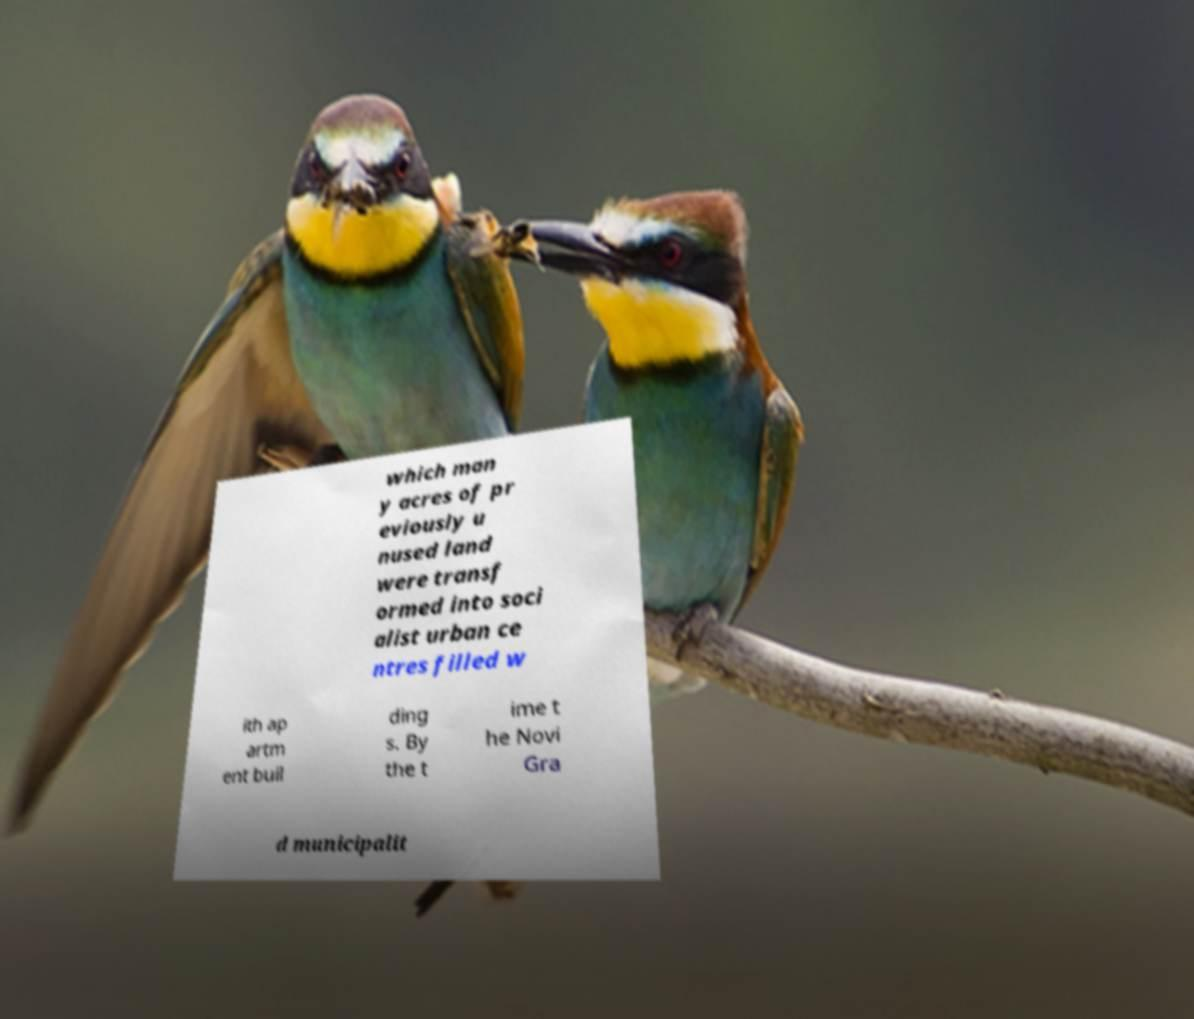What messages or text are displayed in this image? I need them in a readable, typed format. which man y acres of pr eviously u nused land were transf ormed into soci alist urban ce ntres filled w ith ap artm ent buil ding s. By the t ime t he Novi Gra d municipalit 